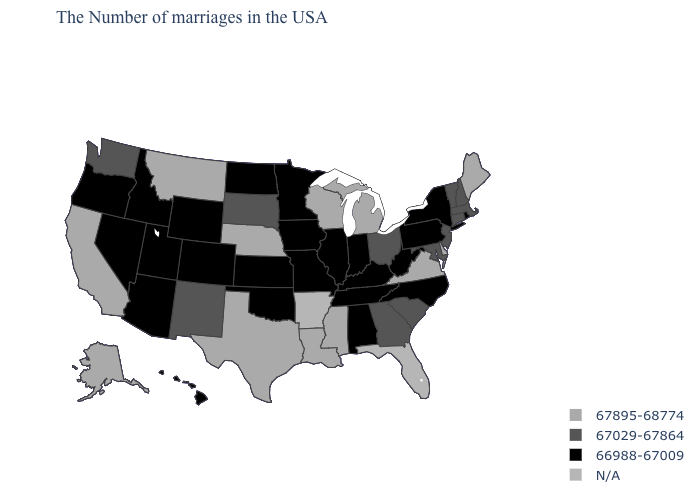Which states hav the highest value in the South?
Be succinct. Delaware, Virginia, Mississippi, Louisiana, Texas. What is the value of Virginia?
Be succinct. 67895-68774. Is the legend a continuous bar?
Quick response, please. No. Name the states that have a value in the range 67895-68774?
Concise answer only. Maine, Delaware, Virginia, Michigan, Wisconsin, Mississippi, Louisiana, Nebraska, Texas, Montana, California, Alaska. What is the value of Georgia?
Quick response, please. 67029-67864. Among the states that border Arizona , which have the highest value?
Write a very short answer. California. Does Maryland have the highest value in the South?
Write a very short answer. No. What is the value of Massachusetts?
Keep it brief. 67029-67864. What is the value of Kentucky?
Short answer required. 66988-67009. What is the highest value in states that border Pennsylvania?
Short answer required. 67895-68774. Which states hav the highest value in the South?
Write a very short answer. Delaware, Virginia, Mississippi, Louisiana, Texas. Among the states that border Ohio , which have the lowest value?
Be succinct. Pennsylvania, West Virginia, Kentucky, Indiana. Is the legend a continuous bar?
Keep it brief. No. Name the states that have a value in the range 67895-68774?
Quick response, please. Maine, Delaware, Virginia, Michigan, Wisconsin, Mississippi, Louisiana, Nebraska, Texas, Montana, California, Alaska. 